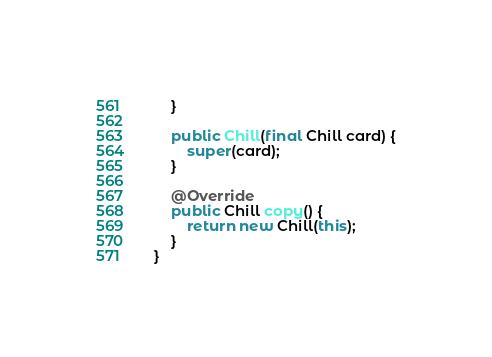<code> <loc_0><loc_0><loc_500><loc_500><_Java_>    }

    public Chill(final Chill card) {
        super(card);
    }

    @Override
    public Chill copy() {
        return new Chill(this);
    }
}
</code> 